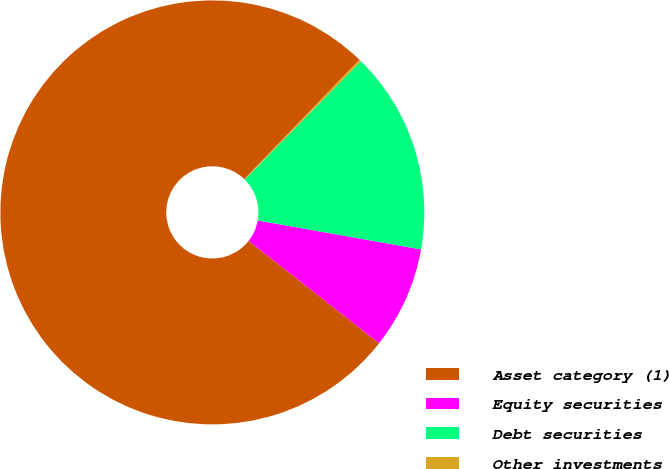<chart> <loc_0><loc_0><loc_500><loc_500><pie_chart><fcel>Asset category (1)<fcel>Equity securities<fcel>Debt securities<fcel>Other investments<nl><fcel>76.61%<fcel>7.8%<fcel>15.44%<fcel>0.15%<nl></chart> 